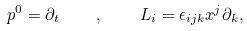Convert formula to latex. <formula><loc_0><loc_0><loc_500><loc_500>p ^ { 0 } = \partial _ { t } \quad , \quad L _ { i } = \epsilon _ { i j k } x ^ { j } \partial _ { k } ,</formula> 